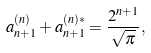<formula> <loc_0><loc_0><loc_500><loc_500>a ^ { ( n ) } _ { n + 1 } + a ^ { ( n ) * } _ { n + 1 } = \frac { 2 ^ { n + 1 } } { \sqrt { \pi } } ,</formula> 